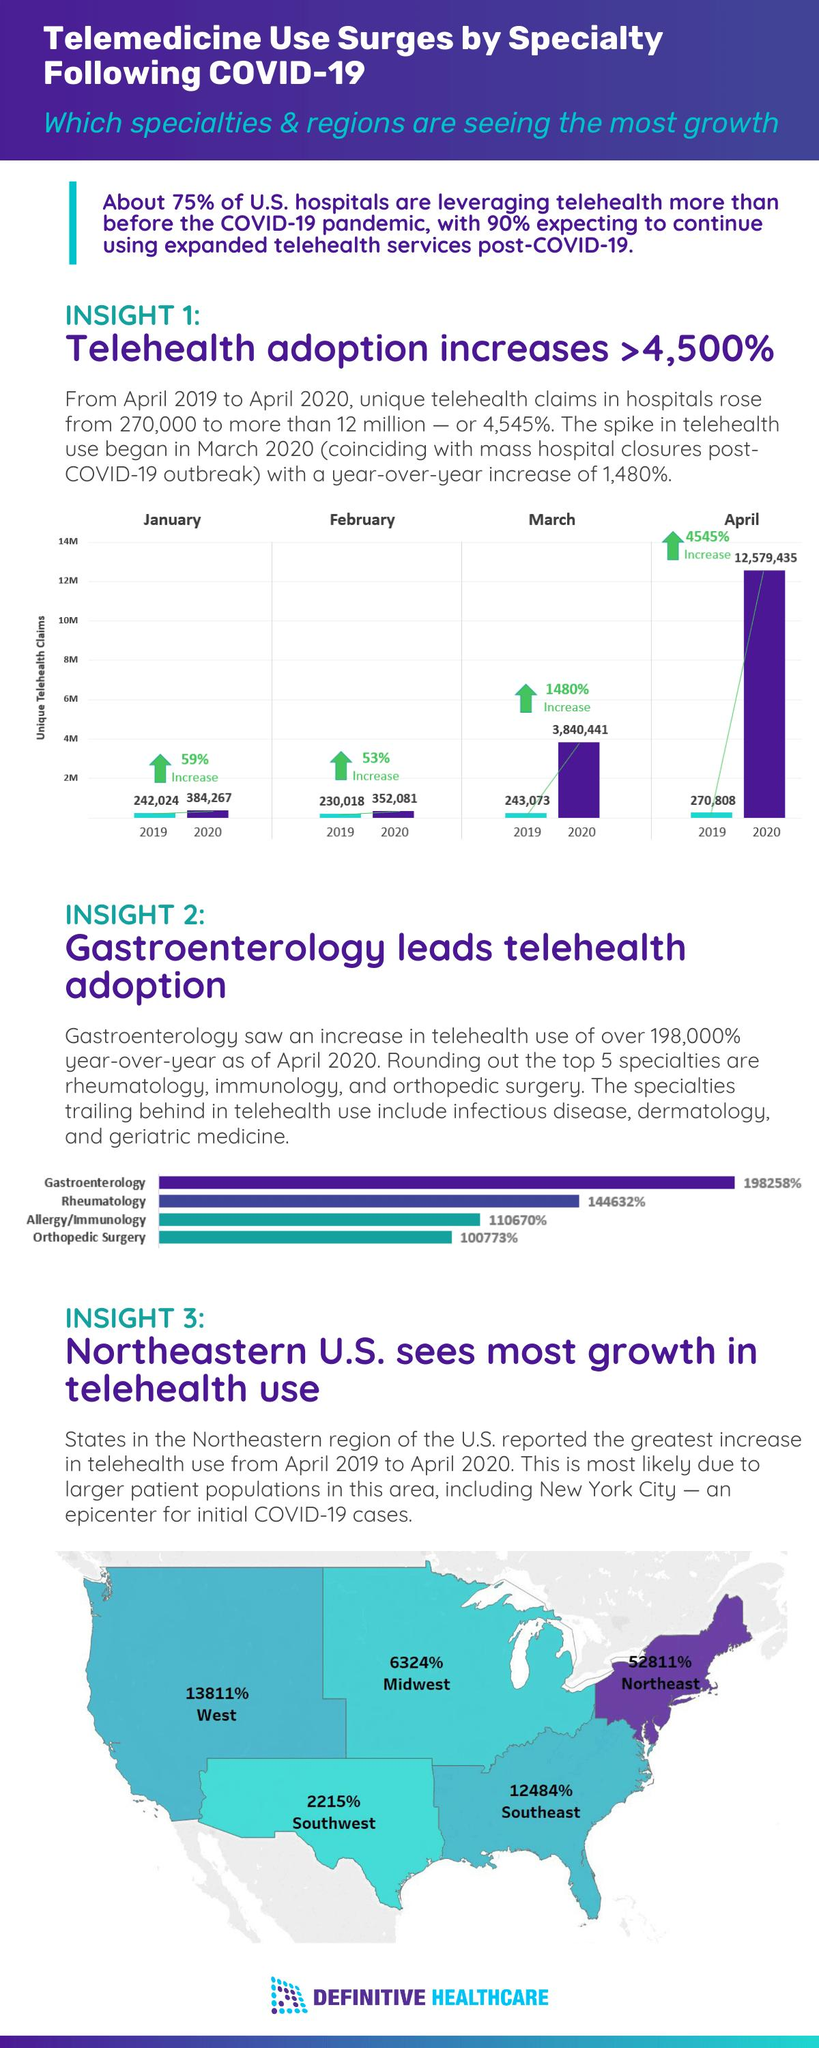Give some essential details in this illustration. In April 2020, a total of 12,579,435 telehealth claims were reported in U.S. hospitals. There is a region in the United States that reported the smallest increase in telehealth use from April 2019 to April 2020, which is the Southwest region. The year-over-year growth rate of unique telehealth claims in U.S. hospitals as of April 2020 was 4,545%. The use of telehealth in the midwest region of the U.S. increased by 6,324% from April 2019 to April 2020. In March 2020, a total of 3,840,441 telehealth claims were reported in U.S. hospitals. 